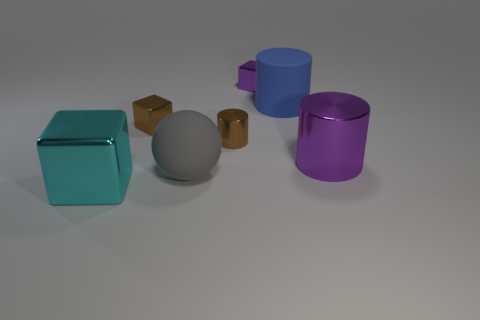Subtract all tiny purple shiny blocks. How many blocks are left? 2 Subtract all cylinders. How many objects are left? 4 Add 2 big gray spheres. How many objects exist? 9 Subtract all brown cylinders. How many cylinders are left? 2 Subtract 3 cylinders. How many cylinders are left? 0 Subtract all brown balls. Subtract all blue blocks. How many balls are left? 1 Subtract all big cyan blocks. Subtract all cubes. How many objects are left? 3 Add 4 purple metal cylinders. How many purple metal cylinders are left? 5 Add 5 tiny brown metallic cylinders. How many tiny brown metallic cylinders exist? 6 Subtract 1 gray balls. How many objects are left? 6 